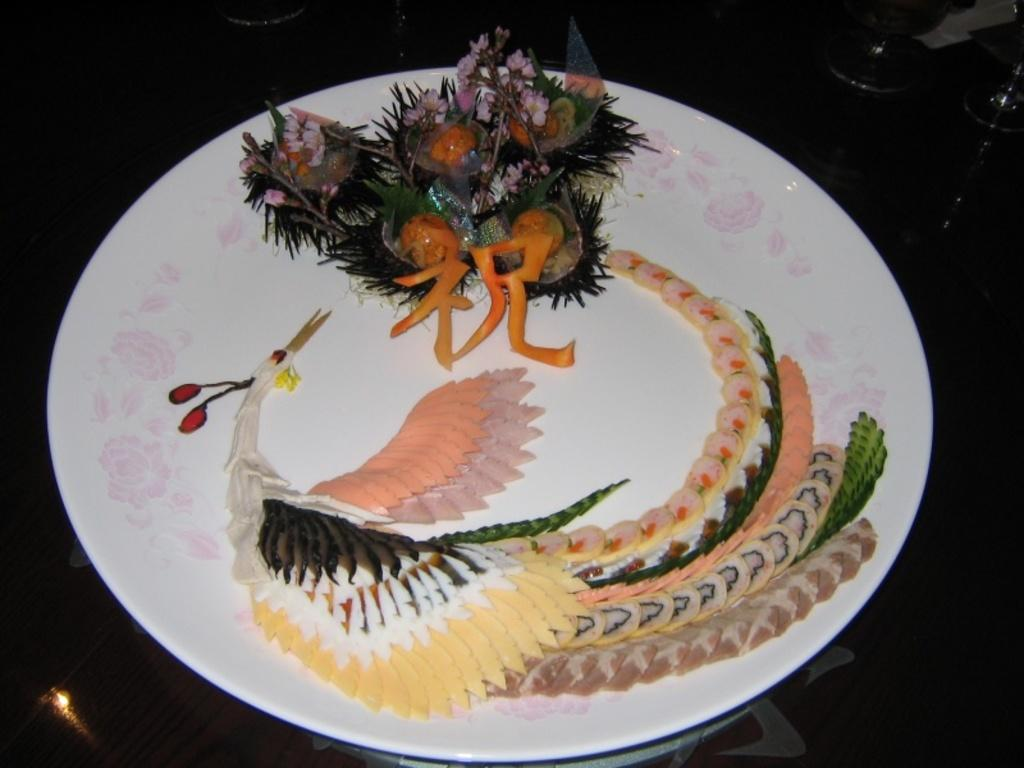What is present on the plate in the image? There are food items on the plate in the image. What color is the plate? The plate is white in color. What can be observed about the surface surrounding the plate? The surface surrounding the plate is dark. What type of holiday is being celebrated in the image? There is no indication of a holiday being celebrated in the image. What texture can be seen on the plate in the image? The texture of the plate cannot be determined from the image, as it only provides information about the color of the plate. 